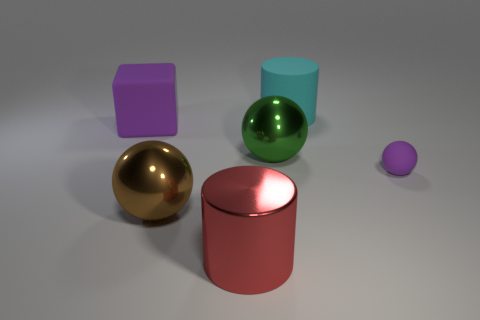Add 2 green metal cylinders. How many objects exist? 8 Subtract all cubes. How many objects are left? 5 Add 6 large metal balls. How many large metal balls are left? 8 Add 3 large cyan blocks. How many large cyan blocks exist? 3 Subtract 0 gray cylinders. How many objects are left? 6 Subtract all small brown rubber cylinders. Subtract all big rubber cylinders. How many objects are left? 5 